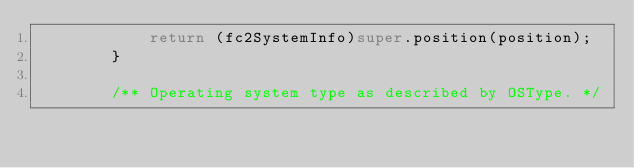<code> <loc_0><loc_0><loc_500><loc_500><_Java_>            return (fc2SystemInfo)super.position(position);
        }
    
        /** Operating system type as described by OSType. */</code> 